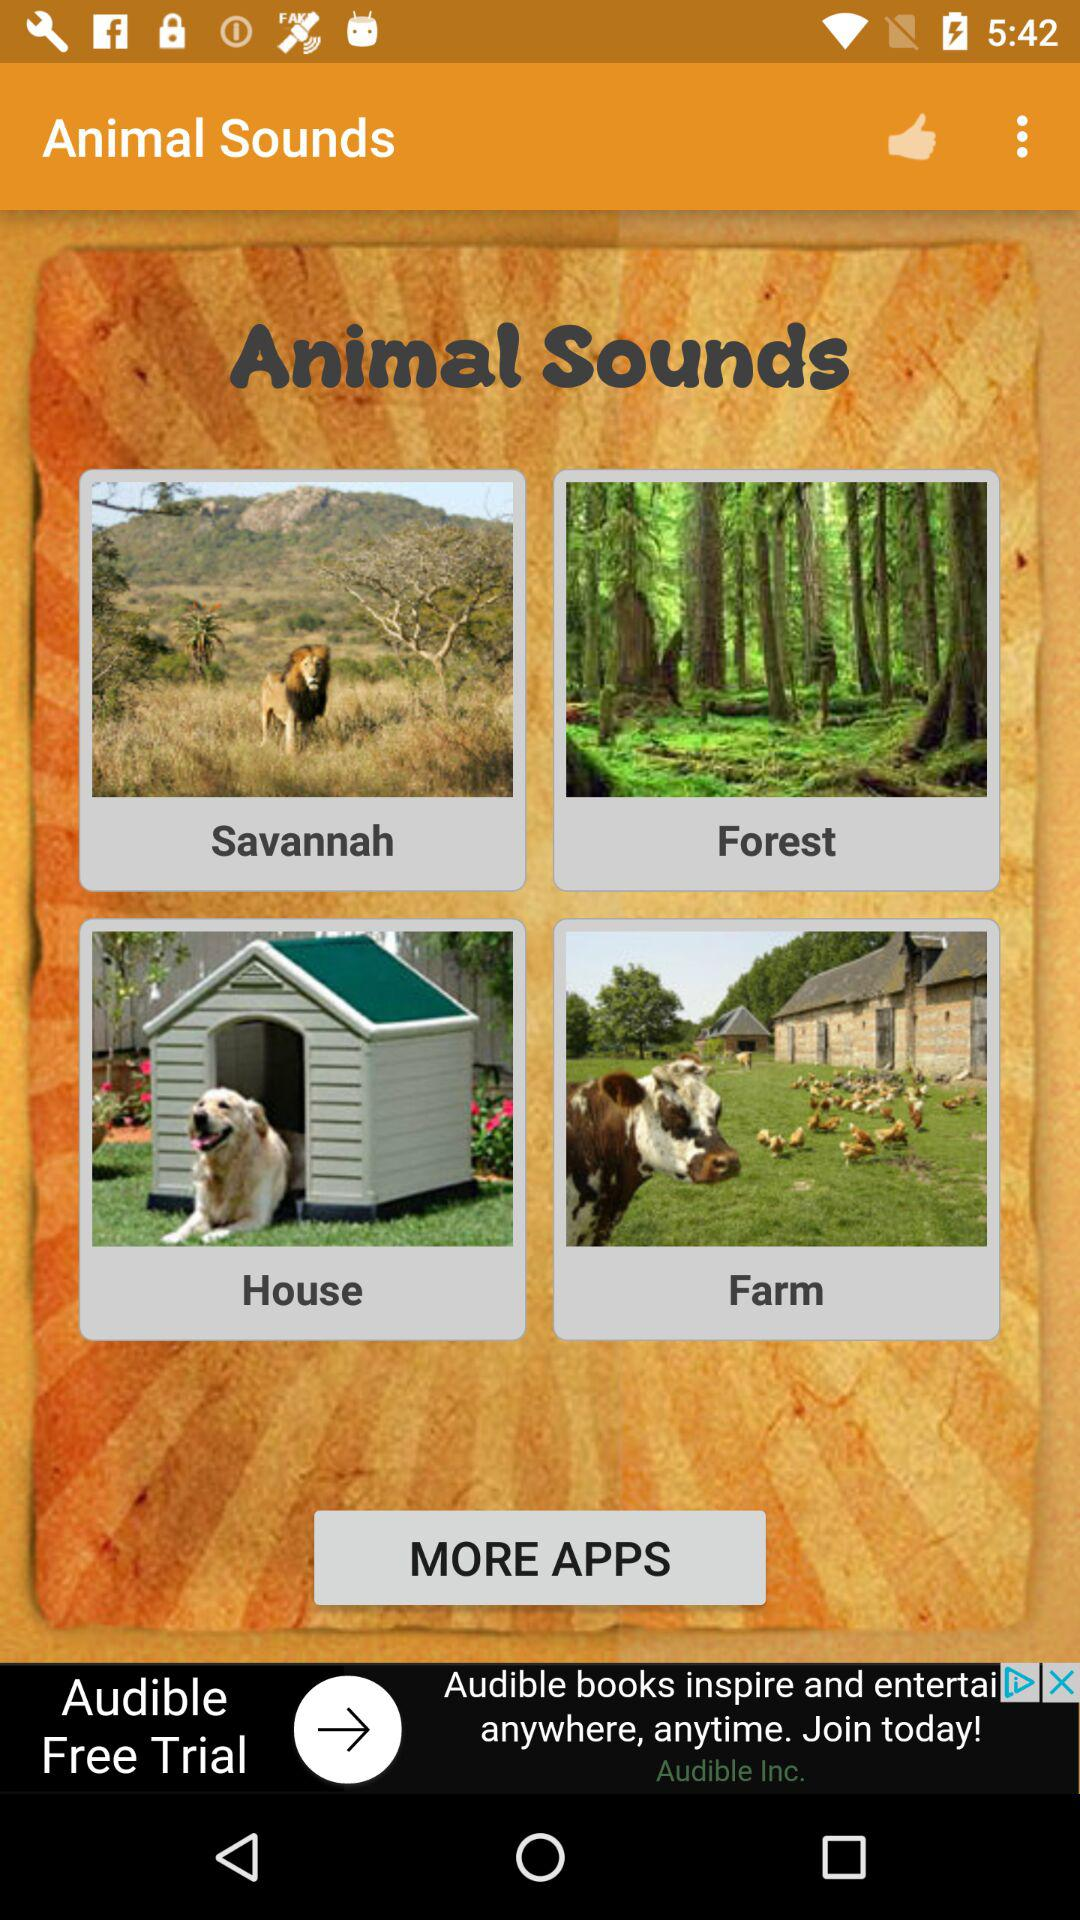What is the name of the application? The name of the application is "Animal Sounds". 